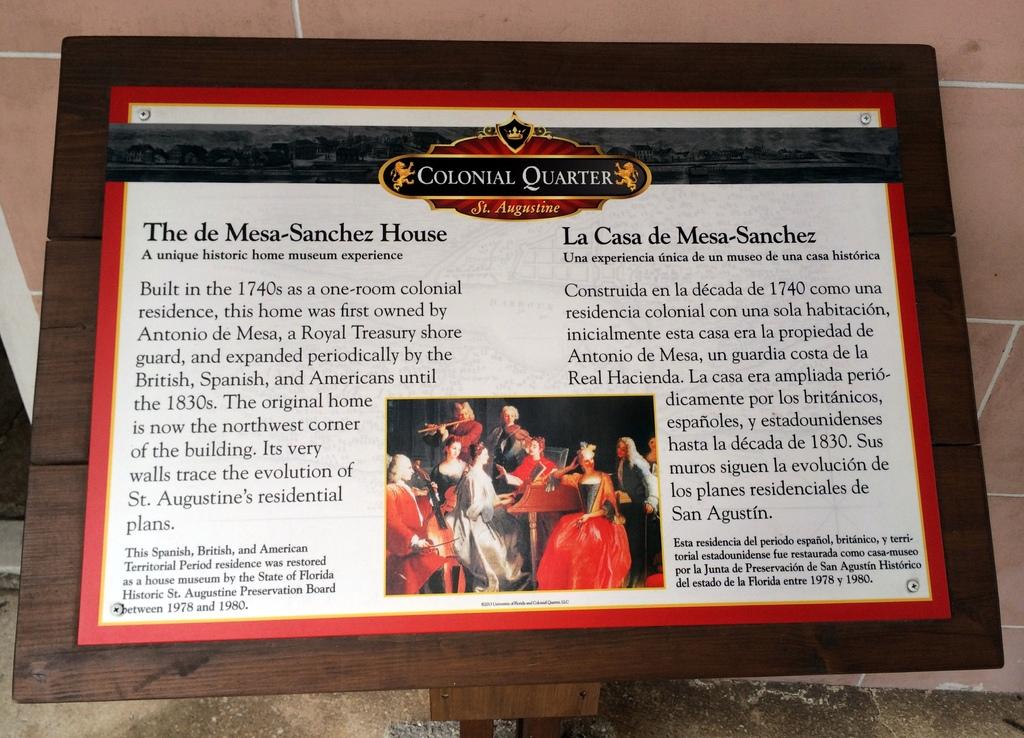Title of this magazine?
Your answer should be very brief. Colonial quarter. Who was the first owner of the de mesa-sanchez house?
Your answer should be compact. Antonio de mesa. 